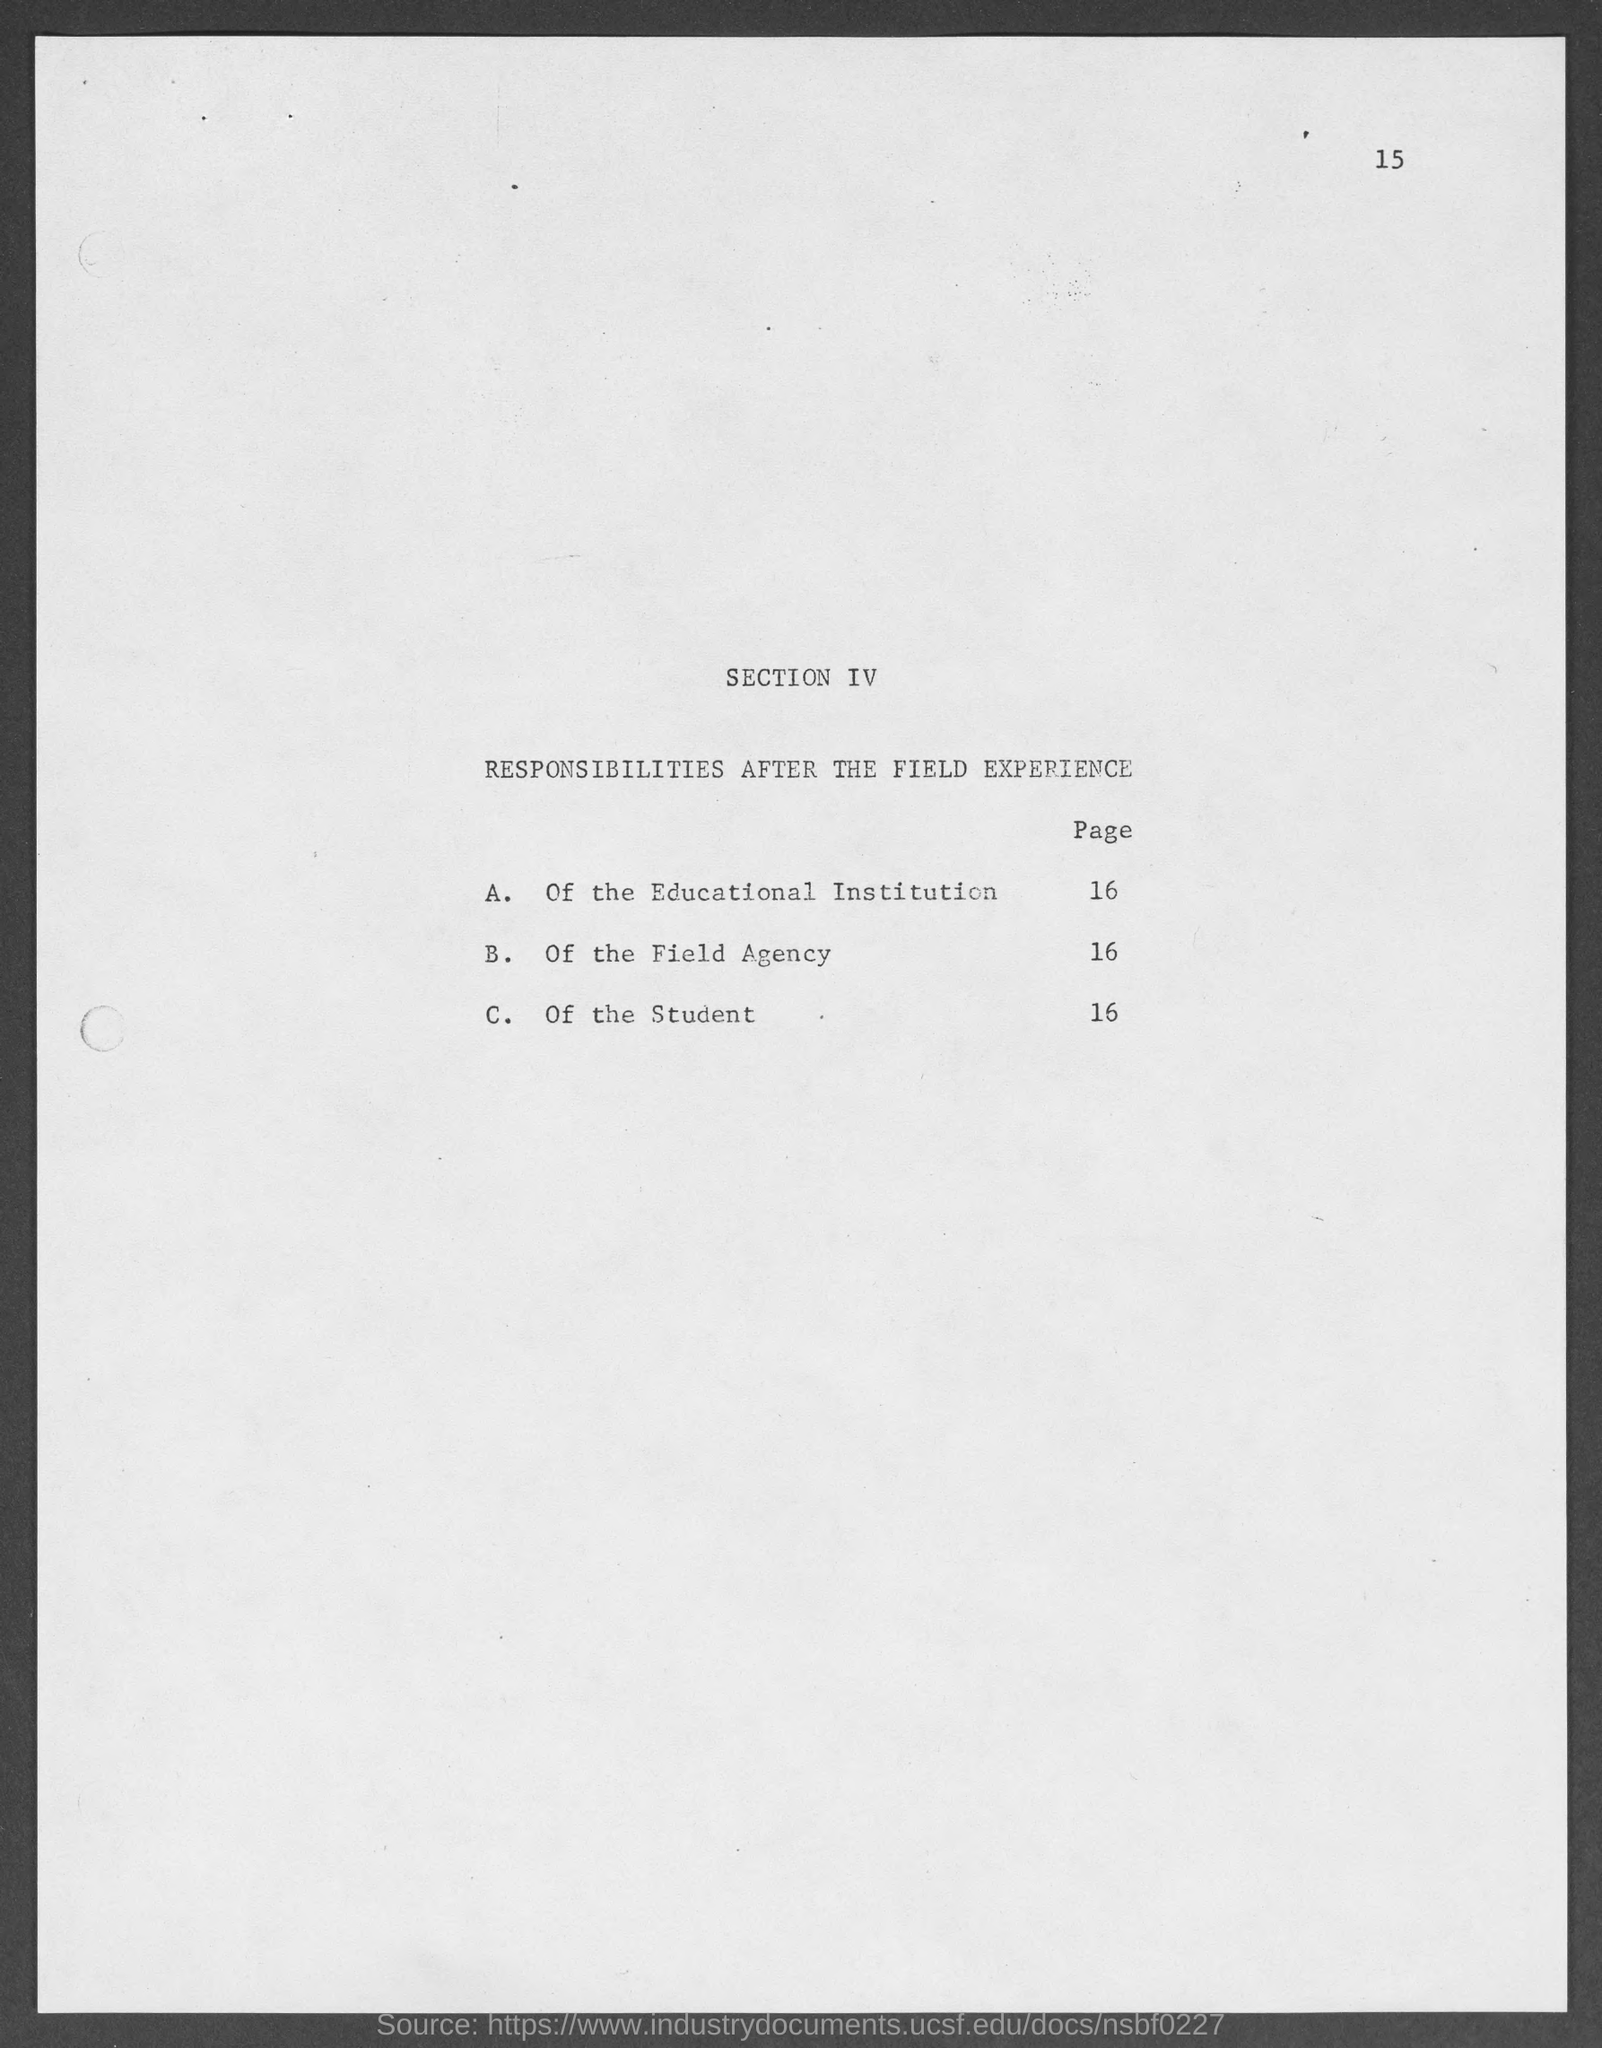What does SECTION IV deal with?
Your answer should be compact. RESPONSIBILITIES AFTER THE FIELD EXPERIENCE. 